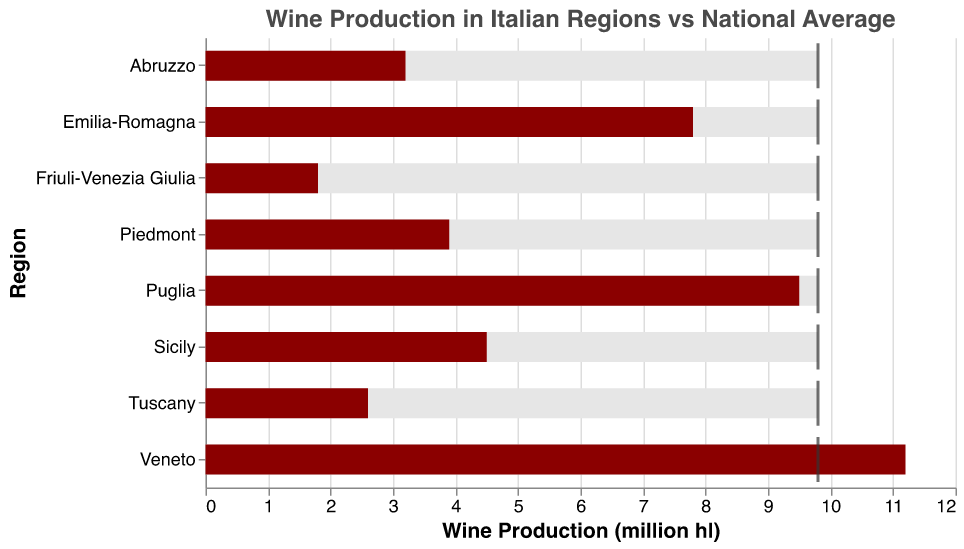What's the title of the chart? The title of the chart is located at the top and reads "Wine Production in Italian Regions vs National Average."
Answer: Wine Production in Italian Regions vs National Average How many regions are shown in the chart? The y-axis lists the regions, and counting them gives us the total number of regions shown.
Answer: 8 Which region has the highest wine production? By looking at the length of the darker bar (representing production) for each region, Veneto has the longest bar.
Answer: Veneto Which regions have wine production lower than the national average? The national average is marked by the tick marks. By comparing the darker bars with these ticks, Puglia, Emilia-Romagna, Sicily, Piedmont, Tuscany, Abruzzo, and Friuli-Venezia Giulia have shorter bars than the tick mark.
Answer: Puglia, Emilia-Romagna, Sicily, Piedmont, Tuscany, Abruzzo, Friuli-Venezia Giulia What's the difference in wine production between Veneto and Tuscany? Veneto produces 11.2 million hl, and Tuscany produces 2.6 million hl. The difference is calculated as 11.2 - 2.6.
Answer: 8.6 million hl Which regions produce more wine than the national average? By comparing the darker bars with the ticks for each region, only Veneto has a longer bar than the tick mark.
Answer: Veneto How much less wine does Sicily produce compared to Piedmont? Sicily produces 4.5 million hl, and Piedmont produces 3.9 million hl. The difference can be calculated as 4.5 - 3.9.
Answer: 0.6 million hl What's the sum of wine production for Abruzzo and Friuli-Venezia Giulia? Abruzzo produces 3.2 million hl and Friuli-Venezia Giulia produces 1.8 million hl. The sum is 3.2 + 1.8.
Answer: 5 million hl Which region has the lowest wine production? By comparing the length of the darker bars, Friuli-Venezia Giulia has the shortest bar, indicating the lowest production.
Answer: Friuli-Venezia Giulia How does Emilia-Romagna’s wine production compare to the national average? Emilia-Romagna has a production of 7.8 million hl and the national average is 9.8 million hl. Comparing these values, Emilia-Romagna's production is lower than the national average.
Answer: Lower 